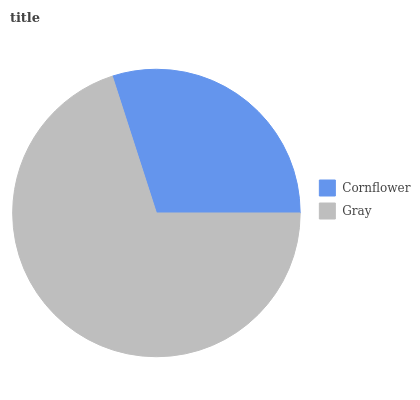Is Cornflower the minimum?
Answer yes or no. Yes. Is Gray the maximum?
Answer yes or no. Yes. Is Gray the minimum?
Answer yes or no. No. Is Gray greater than Cornflower?
Answer yes or no. Yes. Is Cornflower less than Gray?
Answer yes or no. Yes. Is Cornflower greater than Gray?
Answer yes or no. No. Is Gray less than Cornflower?
Answer yes or no. No. Is Gray the high median?
Answer yes or no. Yes. Is Cornflower the low median?
Answer yes or no. Yes. Is Cornflower the high median?
Answer yes or no. No. Is Gray the low median?
Answer yes or no. No. 